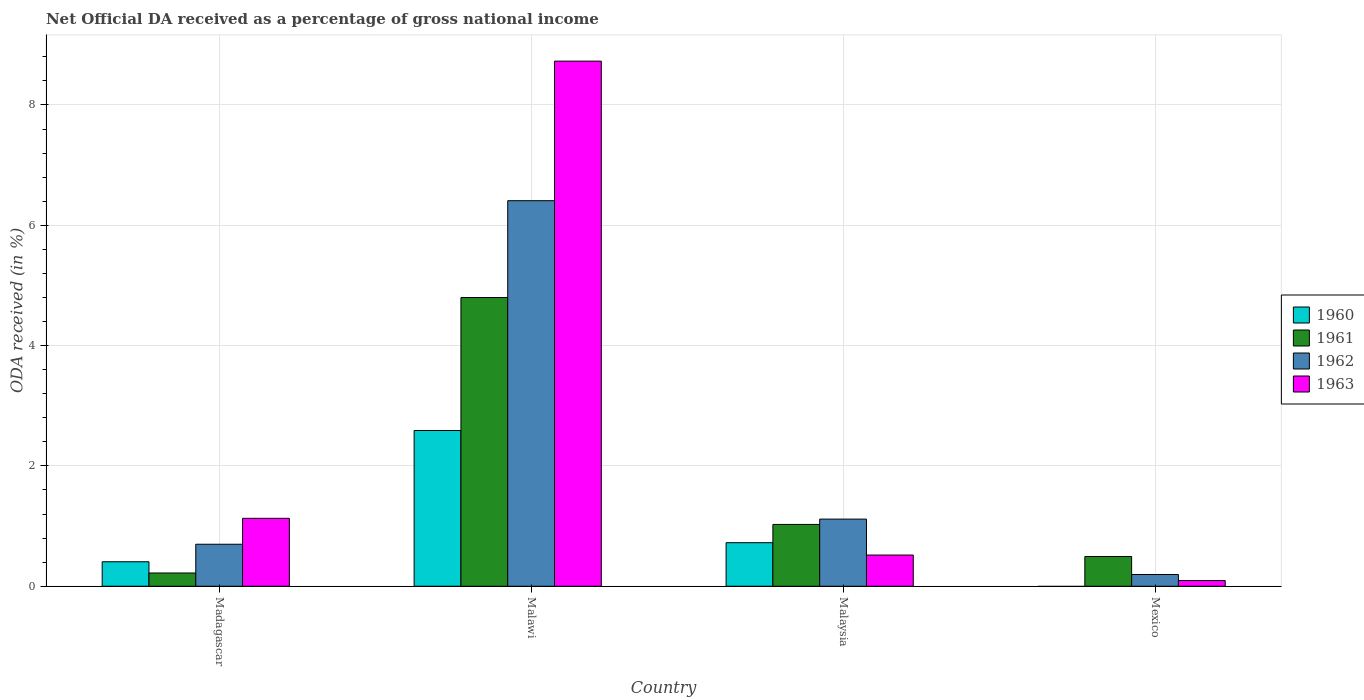How many different coloured bars are there?
Offer a very short reply. 4. Are the number of bars on each tick of the X-axis equal?
Keep it short and to the point. No. How many bars are there on the 4th tick from the left?
Provide a succinct answer. 3. How many bars are there on the 3rd tick from the right?
Provide a succinct answer. 4. What is the label of the 2nd group of bars from the left?
Offer a very short reply. Malawi. What is the net official DA received in 1961 in Malaysia?
Offer a very short reply. 1.03. Across all countries, what is the maximum net official DA received in 1961?
Your response must be concise. 4.8. Across all countries, what is the minimum net official DA received in 1963?
Give a very brief answer. 0.09. In which country was the net official DA received in 1961 maximum?
Offer a terse response. Malawi. What is the total net official DA received in 1960 in the graph?
Offer a terse response. 3.72. What is the difference between the net official DA received in 1961 in Malawi and that in Mexico?
Offer a very short reply. 4.3. What is the difference between the net official DA received in 1962 in Malaysia and the net official DA received in 1961 in Mexico?
Provide a succinct answer. 0.62. What is the average net official DA received in 1962 per country?
Provide a short and direct response. 2.1. What is the difference between the net official DA received of/in 1960 and net official DA received of/in 1961 in Malaysia?
Ensure brevity in your answer.  -0.3. In how many countries, is the net official DA received in 1960 greater than 6.8 %?
Your answer should be very brief. 0. What is the ratio of the net official DA received in 1963 in Madagascar to that in Mexico?
Offer a terse response. 11.92. Is the net official DA received in 1962 in Madagascar less than that in Malawi?
Give a very brief answer. Yes. What is the difference between the highest and the second highest net official DA received in 1962?
Give a very brief answer. -0.42. What is the difference between the highest and the lowest net official DA received in 1963?
Make the answer very short. 8.63. In how many countries, is the net official DA received in 1960 greater than the average net official DA received in 1960 taken over all countries?
Give a very brief answer. 1. Is the sum of the net official DA received in 1960 in Madagascar and Malaysia greater than the maximum net official DA received in 1963 across all countries?
Your answer should be compact. No. Is it the case that in every country, the sum of the net official DA received in 1962 and net official DA received in 1960 is greater than the sum of net official DA received in 1961 and net official DA received in 1963?
Keep it short and to the point. No. Is it the case that in every country, the sum of the net official DA received in 1962 and net official DA received in 1960 is greater than the net official DA received in 1961?
Offer a very short reply. No. Are all the bars in the graph horizontal?
Ensure brevity in your answer.  No. Are the values on the major ticks of Y-axis written in scientific E-notation?
Your response must be concise. No. Does the graph contain any zero values?
Your answer should be compact. Yes. Where does the legend appear in the graph?
Offer a very short reply. Center right. How are the legend labels stacked?
Ensure brevity in your answer.  Vertical. What is the title of the graph?
Make the answer very short. Net Official DA received as a percentage of gross national income. What is the label or title of the Y-axis?
Your answer should be compact. ODA received (in %). What is the ODA received (in %) in 1960 in Madagascar?
Give a very brief answer. 0.41. What is the ODA received (in %) in 1961 in Madagascar?
Give a very brief answer. 0.22. What is the ODA received (in %) in 1962 in Madagascar?
Your response must be concise. 0.7. What is the ODA received (in %) of 1963 in Madagascar?
Offer a terse response. 1.13. What is the ODA received (in %) in 1960 in Malawi?
Your answer should be very brief. 2.59. What is the ODA received (in %) of 1961 in Malawi?
Your response must be concise. 4.8. What is the ODA received (in %) of 1962 in Malawi?
Your answer should be compact. 6.41. What is the ODA received (in %) of 1963 in Malawi?
Provide a short and direct response. 8.73. What is the ODA received (in %) of 1960 in Malaysia?
Make the answer very short. 0.72. What is the ODA received (in %) in 1961 in Malaysia?
Keep it short and to the point. 1.03. What is the ODA received (in %) in 1962 in Malaysia?
Offer a terse response. 1.12. What is the ODA received (in %) in 1963 in Malaysia?
Keep it short and to the point. 0.52. What is the ODA received (in %) in 1960 in Mexico?
Provide a short and direct response. 0. What is the ODA received (in %) in 1961 in Mexico?
Ensure brevity in your answer.  0.49. What is the ODA received (in %) of 1962 in Mexico?
Make the answer very short. 0.2. What is the ODA received (in %) in 1963 in Mexico?
Make the answer very short. 0.09. Across all countries, what is the maximum ODA received (in %) in 1960?
Provide a succinct answer. 2.59. Across all countries, what is the maximum ODA received (in %) of 1961?
Offer a terse response. 4.8. Across all countries, what is the maximum ODA received (in %) of 1962?
Ensure brevity in your answer.  6.41. Across all countries, what is the maximum ODA received (in %) in 1963?
Your answer should be very brief. 8.73. Across all countries, what is the minimum ODA received (in %) of 1961?
Provide a short and direct response. 0.22. Across all countries, what is the minimum ODA received (in %) of 1962?
Give a very brief answer. 0.2. Across all countries, what is the minimum ODA received (in %) in 1963?
Offer a terse response. 0.09. What is the total ODA received (in %) of 1960 in the graph?
Make the answer very short. 3.72. What is the total ODA received (in %) of 1961 in the graph?
Give a very brief answer. 6.54. What is the total ODA received (in %) in 1962 in the graph?
Make the answer very short. 8.42. What is the total ODA received (in %) of 1963 in the graph?
Your response must be concise. 10.47. What is the difference between the ODA received (in %) of 1960 in Madagascar and that in Malawi?
Provide a short and direct response. -2.18. What is the difference between the ODA received (in %) of 1961 in Madagascar and that in Malawi?
Provide a succinct answer. -4.58. What is the difference between the ODA received (in %) in 1962 in Madagascar and that in Malawi?
Your answer should be compact. -5.71. What is the difference between the ODA received (in %) in 1963 in Madagascar and that in Malawi?
Your answer should be very brief. -7.6. What is the difference between the ODA received (in %) of 1960 in Madagascar and that in Malaysia?
Your answer should be compact. -0.32. What is the difference between the ODA received (in %) in 1961 in Madagascar and that in Malaysia?
Your answer should be compact. -0.81. What is the difference between the ODA received (in %) of 1962 in Madagascar and that in Malaysia?
Give a very brief answer. -0.42. What is the difference between the ODA received (in %) of 1963 in Madagascar and that in Malaysia?
Provide a short and direct response. 0.61. What is the difference between the ODA received (in %) of 1961 in Madagascar and that in Mexico?
Ensure brevity in your answer.  -0.27. What is the difference between the ODA received (in %) in 1962 in Madagascar and that in Mexico?
Your response must be concise. 0.5. What is the difference between the ODA received (in %) of 1963 in Madagascar and that in Mexico?
Offer a terse response. 1.03. What is the difference between the ODA received (in %) of 1960 in Malawi and that in Malaysia?
Your response must be concise. 1.86. What is the difference between the ODA received (in %) in 1961 in Malawi and that in Malaysia?
Give a very brief answer. 3.77. What is the difference between the ODA received (in %) of 1962 in Malawi and that in Malaysia?
Your response must be concise. 5.29. What is the difference between the ODA received (in %) of 1963 in Malawi and that in Malaysia?
Your response must be concise. 8.21. What is the difference between the ODA received (in %) in 1961 in Malawi and that in Mexico?
Your answer should be very brief. 4.3. What is the difference between the ODA received (in %) in 1962 in Malawi and that in Mexico?
Offer a terse response. 6.21. What is the difference between the ODA received (in %) in 1963 in Malawi and that in Mexico?
Your answer should be compact. 8.63. What is the difference between the ODA received (in %) in 1961 in Malaysia and that in Mexico?
Your answer should be very brief. 0.53. What is the difference between the ODA received (in %) of 1962 in Malaysia and that in Mexico?
Give a very brief answer. 0.92. What is the difference between the ODA received (in %) of 1963 in Malaysia and that in Mexico?
Offer a terse response. 0.42. What is the difference between the ODA received (in %) of 1960 in Madagascar and the ODA received (in %) of 1961 in Malawi?
Offer a terse response. -4.39. What is the difference between the ODA received (in %) in 1960 in Madagascar and the ODA received (in %) in 1962 in Malawi?
Keep it short and to the point. -6. What is the difference between the ODA received (in %) of 1960 in Madagascar and the ODA received (in %) of 1963 in Malawi?
Ensure brevity in your answer.  -8.32. What is the difference between the ODA received (in %) in 1961 in Madagascar and the ODA received (in %) in 1962 in Malawi?
Offer a terse response. -6.19. What is the difference between the ODA received (in %) in 1961 in Madagascar and the ODA received (in %) in 1963 in Malawi?
Your answer should be very brief. -8.51. What is the difference between the ODA received (in %) in 1962 in Madagascar and the ODA received (in %) in 1963 in Malawi?
Offer a very short reply. -8.03. What is the difference between the ODA received (in %) of 1960 in Madagascar and the ODA received (in %) of 1961 in Malaysia?
Your answer should be compact. -0.62. What is the difference between the ODA received (in %) of 1960 in Madagascar and the ODA received (in %) of 1962 in Malaysia?
Offer a very short reply. -0.71. What is the difference between the ODA received (in %) of 1960 in Madagascar and the ODA received (in %) of 1963 in Malaysia?
Your answer should be compact. -0.11. What is the difference between the ODA received (in %) in 1961 in Madagascar and the ODA received (in %) in 1962 in Malaysia?
Offer a terse response. -0.9. What is the difference between the ODA received (in %) in 1961 in Madagascar and the ODA received (in %) in 1963 in Malaysia?
Provide a succinct answer. -0.3. What is the difference between the ODA received (in %) in 1962 in Madagascar and the ODA received (in %) in 1963 in Malaysia?
Your answer should be very brief. 0.18. What is the difference between the ODA received (in %) of 1960 in Madagascar and the ODA received (in %) of 1961 in Mexico?
Your response must be concise. -0.09. What is the difference between the ODA received (in %) in 1960 in Madagascar and the ODA received (in %) in 1962 in Mexico?
Your answer should be very brief. 0.21. What is the difference between the ODA received (in %) in 1960 in Madagascar and the ODA received (in %) in 1963 in Mexico?
Offer a terse response. 0.31. What is the difference between the ODA received (in %) of 1961 in Madagascar and the ODA received (in %) of 1962 in Mexico?
Offer a very short reply. 0.03. What is the difference between the ODA received (in %) in 1961 in Madagascar and the ODA received (in %) in 1963 in Mexico?
Your answer should be compact. 0.13. What is the difference between the ODA received (in %) of 1962 in Madagascar and the ODA received (in %) of 1963 in Mexico?
Make the answer very short. 0.6. What is the difference between the ODA received (in %) in 1960 in Malawi and the ODA received (in %) in 1961 in Malaysia?
Provide a succinct answer. 1.56. What is the difference between the ODA received (in %) of 1960 in Malawi and the ODA received (in %) of 1962 in Malaysia?
Keep it short and to the point. 1.47. What is the difference between the ODA received (in %) in 1960 in Malawi and the ODA received (in %) in 1963 in Malaysia?
Offer a very short reply. 2.07. What is the difference between the ODA received (in %) of 1961 in Malawi and the ODA received (in %) of 1962 in Malaysia?
Your response must be concise. 3.68. What is the difference between the ODA received (in %) of 1961 in Malawi and the ODA received (in %) of 1963 in Malaysia?
Provide a short and direct response. 4.28. What is the difference between the ODA received (in %) of 1962 in Malawi and the ODA received (in %) of 1963 in Malaysia?
Offer a very short reply. 5.89. What is the difference between the ODA received (in %) in 1960 in Malawi and the ODA received (in %) in 1961 in Mexico?
Provide a succinct answer. 2.09. What is the difference between the ODA received (in %) of 1960 in Malawi and the ODA received (in %) of 1962 in Mexico?
Your answer should be compact. 2.39. What is the difference between the ODA received (in %) in 1960 in Malawi and the ODA received (in %) in 1963 in Mexico?
Give a very brief answer. 2.49. What is the difference between the ODA received (in %) in 1961 in Malawi and the ODA received (in %) in 1962 in Mexico?
Give a very brief answer. 4.6. What is the difference between the ODA received (in %) of 1961 in Malawi and the ODA received (in %) of 1963 in Mexico?
Offer a terse response. 4.7. What is the difference between the ODA received (in %) in 1962 in Malawi and the ODA received (in %) in 1963 in Mexico?
Your answer should be very brief. 6.31. What is the difference between the ODA received (in %) of 1960 in Malaysia and the ODA received (in %) of 1961 in Mexico?
Your answer should be very brief. 0.23. What is the difference between the ODA received (in %) in 1960 in Malaysia and the ODA received (in %) in 1962 in Mexico?
Your answer should be very brief. 0.53. What is the difference between the ODA received (in %) in 1960 in Malaysia and the ODA received (in %) in 1963 in Mexico?
Ensure brevity in your answer.  0.63. What is the difference between the ODA received (in %) of 1961 in Malaysia and the ODA received (in %) of 1962 in Mexico?
Provide a succinct answer. 0.83. What is the difference between the ODA received (in %) in 1961 in Malaysia and the ODA received (in %) in 1963 in Mexico?
Give a very brief answer. 0.93. What is the difference between the ODA received (in %) in 1962 in Malaysia and the ODA received (in %) in 1963 in Mexico?
Offer a very short reply. 1.02. What is the average ODA received (in %) of 1960 per country?
Offer a very short reply. 0.93. What is the average ODA received (in %) in 1961 per country?
Ensure brevity in your answer.  1.64. What is the average ODA received (in %) of 1962 per country?
Give a very brief answer. 2.1. What is the average ODA received (in %) in 1963 per country?
Your response must be concise. 2.62. What is the difference between the ODA received (in %) of 1960 and ODA received (in %) of 1961 in Madagascar?
Offer a terse response. 0.19. What is the difference between the ODA received (in %) of 1960 and ODA received (in %) of 1962 in Madagascar?
Your answer should be compact. -0.29. What is the difference between the ODA received (in %) of 1960 and ODA received (in %) of 1963 in Madagascar?
Offer a terse response. -0.72. What is the difference between the ODA received (in %) of 1961 and ODA received (in %) of 1962 in Madagascar?
Give a very brief answer. -0.48. What is the difference between the ODA received (in %) in 1961 and ODA received (in %) in 1963 in Madagascar?
Offer a very short reply. -0.91. What is the difference between the ODA received (in %) of 1962 and ODA received (in %) of 1963 in Madagascar?
Offer a very short reply. -0.43. What is the difference between the ODA received (in %) of 1960 and ODA received (in %) of 1961 in Malawi?
Your response must be concise. -2.21. What is the difference between the ODA received (in %) in 1960 and ODA received (in %) in 1962 in Malawi?
Your answer should be compact. -3.82. What is the difference between the ODA received (in %) of 1960 and ODA received (in %) of 1963 in Malawi?
Keep it short and to the point. -6.14. What is the difference between the ODA received (in %) of 1961 and ODA received (in %) of 1962 in Malawi?
Your answer should be compact. -1.61. What is the difference between the ODA received (in %) in 1961 and ODA received (in %) in 1963 in Malawi?
Give a very brief answer. -3.93. What is the difference between the ODA received (in %) in 1962 and ODA received (in %) in 1963 in Malawi?
Your answer should be very brief. -2.32. What is the difference between the ODA received (in %) in 1960 and ODA received (in %) in 1961 in Malaysia?
Your answer should be very brief. -0.3. What is the difference between the ODA received (in %) of 1960 and ODA received (in %) of 1962 in Malaysia?
Your response must be concise. -0.39. What is the difference between the ODA received (in %) of 1960 and ODA received (in %) of 1963 in Malaysia?
Your response must be concise. 0.21. What is the difference between the ODA received (in %) in 1961 and ODA received (in %) in 1962 in Malaysia?
Keep it short and to the point. -0.09. What is the difference between the ODA received (in %) of 1961 and ODA received (in %) of 1963 in Malaysia?
Offer a terse response. 0.51. What is the difference between the ODA received (in %) of 1962 and ODA received (in %) of 1963 in Malaysia?
Keep it short and to the point. 0.6. What is the difference between the ODA received (in %) of 1961 and ODA received (in %) of 1962 in Mexico?
Provide a succinct answer. 0.3. What is the difference between the ODA received (in %) in 1961 and ODA received (in %) in 1963 in Mexico?
Your answer should be very brief. 0.4. What is the difference between the ODA received (in %) in 1962 and ODA received (in %) in 1963 in Mexico?
Your answer should be very brief. 0.1. What is the ratio of the ODA received (in %) in 1960 in Madagascar to that in Malawi?
Give a very brief answer. 0.16. What is the ratio of the ODA received (in %) in 1961 in Madagascar to that in Malawi?
Give a very brief answer. 0.05. What is the ratio of the ODA received (in %) of 1962 in Madagascar to that in Malawi?
Make the answer very short. 0.11. What is the ratio of the ODA received (in %) in 1963 in Madagascar to that in Malawi?
Offer a terse response. 0.13. What is the ratio of the ODA received (in %) in 1960 in Madagascar to that in Malaysia?
Your answer should be very brief. 0.56. What is the ratio of the ODA received (in %) of 1961 in Madagascar to that in Malaysia?
Ensure brevity in your answer.  0.21. What is the ratio of the ODA received (in %) of 1962 in Madagascar to that in Malaysia?
Ensure brevity in your answer.  0.63. What is the ratio of the ODA received (in %) of 1963 in Madagascar to that in Malaysia?
Your response must be concise. 2.18. What is the ratio of the ODA received (in %) of 1961 in Madagascar to that in Mexico?
Make the answer very short. 0.45. What is the ratio of the ODA received (in %) in 1962 in Madagascar to that in Mexico?
Offer a very short reply. 3.58. What is the ratio of the ODA received (in %) in 1963 in Madagascar to that in Mexico?
Offer a terse response. 11.92. What is the ratio of the ODA received (in %) of 1960 in Malawi to that in Malaysia?
Your response must be concise. 3.58. What is the ratio of the ODA received (in %) in 1961 in Malawi to that in Malaysia?
Your answer should be very brief. 4.67. What is the ratio of the ODA received (in %) of 1962 in Malawi to that in Malaysia?
Offer a very short reply. 5.74. What is the ratio of the ODA received (in %) in 1963 in Malawi to that in Malaysia?
Give a very brief answer. 16.83. What is the ratio of the ODA received (in %) in 1962 in Malawi to that in Mexico?
Provide a succinct answer. 32.85. What is the ratio of the ODA received (in %) of 1963 in Malawi to that in Mexico?
Provide a short and direct response. 92.18. What is the ratio of the ODA received (in %) of 1961 in Malaysia to that in Mexico?
Your response must be concise. 2.08. What is the ratio of the ODA received (in %) of 1962 in Malaysia to that in Mexico?
Your answer should be very brief. 5.72. What is the ratio of the ODA received (in %) of 1963 in Malaysia to that in Mexico?
Provide a succinct answer. 5.48. What is the difference between the highest and the second highest ODA received (in %) in 1960?
Keep it short and to the point. 1.86. What is the difference between the highest and the second highest ODA received (in %) of 1961?
Your response must be concise. 3.77. What is the difference between the highest and the second highest ODA received (in %) of 1962?
Keep it short and to the point. 5.29. What is the difference between the highest and the second highest ODA received (in %) in 1963?
Your response must be concise. 7.6. What is the difference between the highest and the lowest ODA received (in %) of 1960?
Your response must be concise. 2.59. What is the difference between the highest and the lowest ODA received (in %) in 1961?
Your response must be concise. 4.58. What is the difference between the highest and the lowest ODA received (in %) of 1962?
Make the answer very short. 6.21. What is the difference between the highest and the lowest ODA received (in %) in 1963?
Provide a short and direct response. 8.63. 